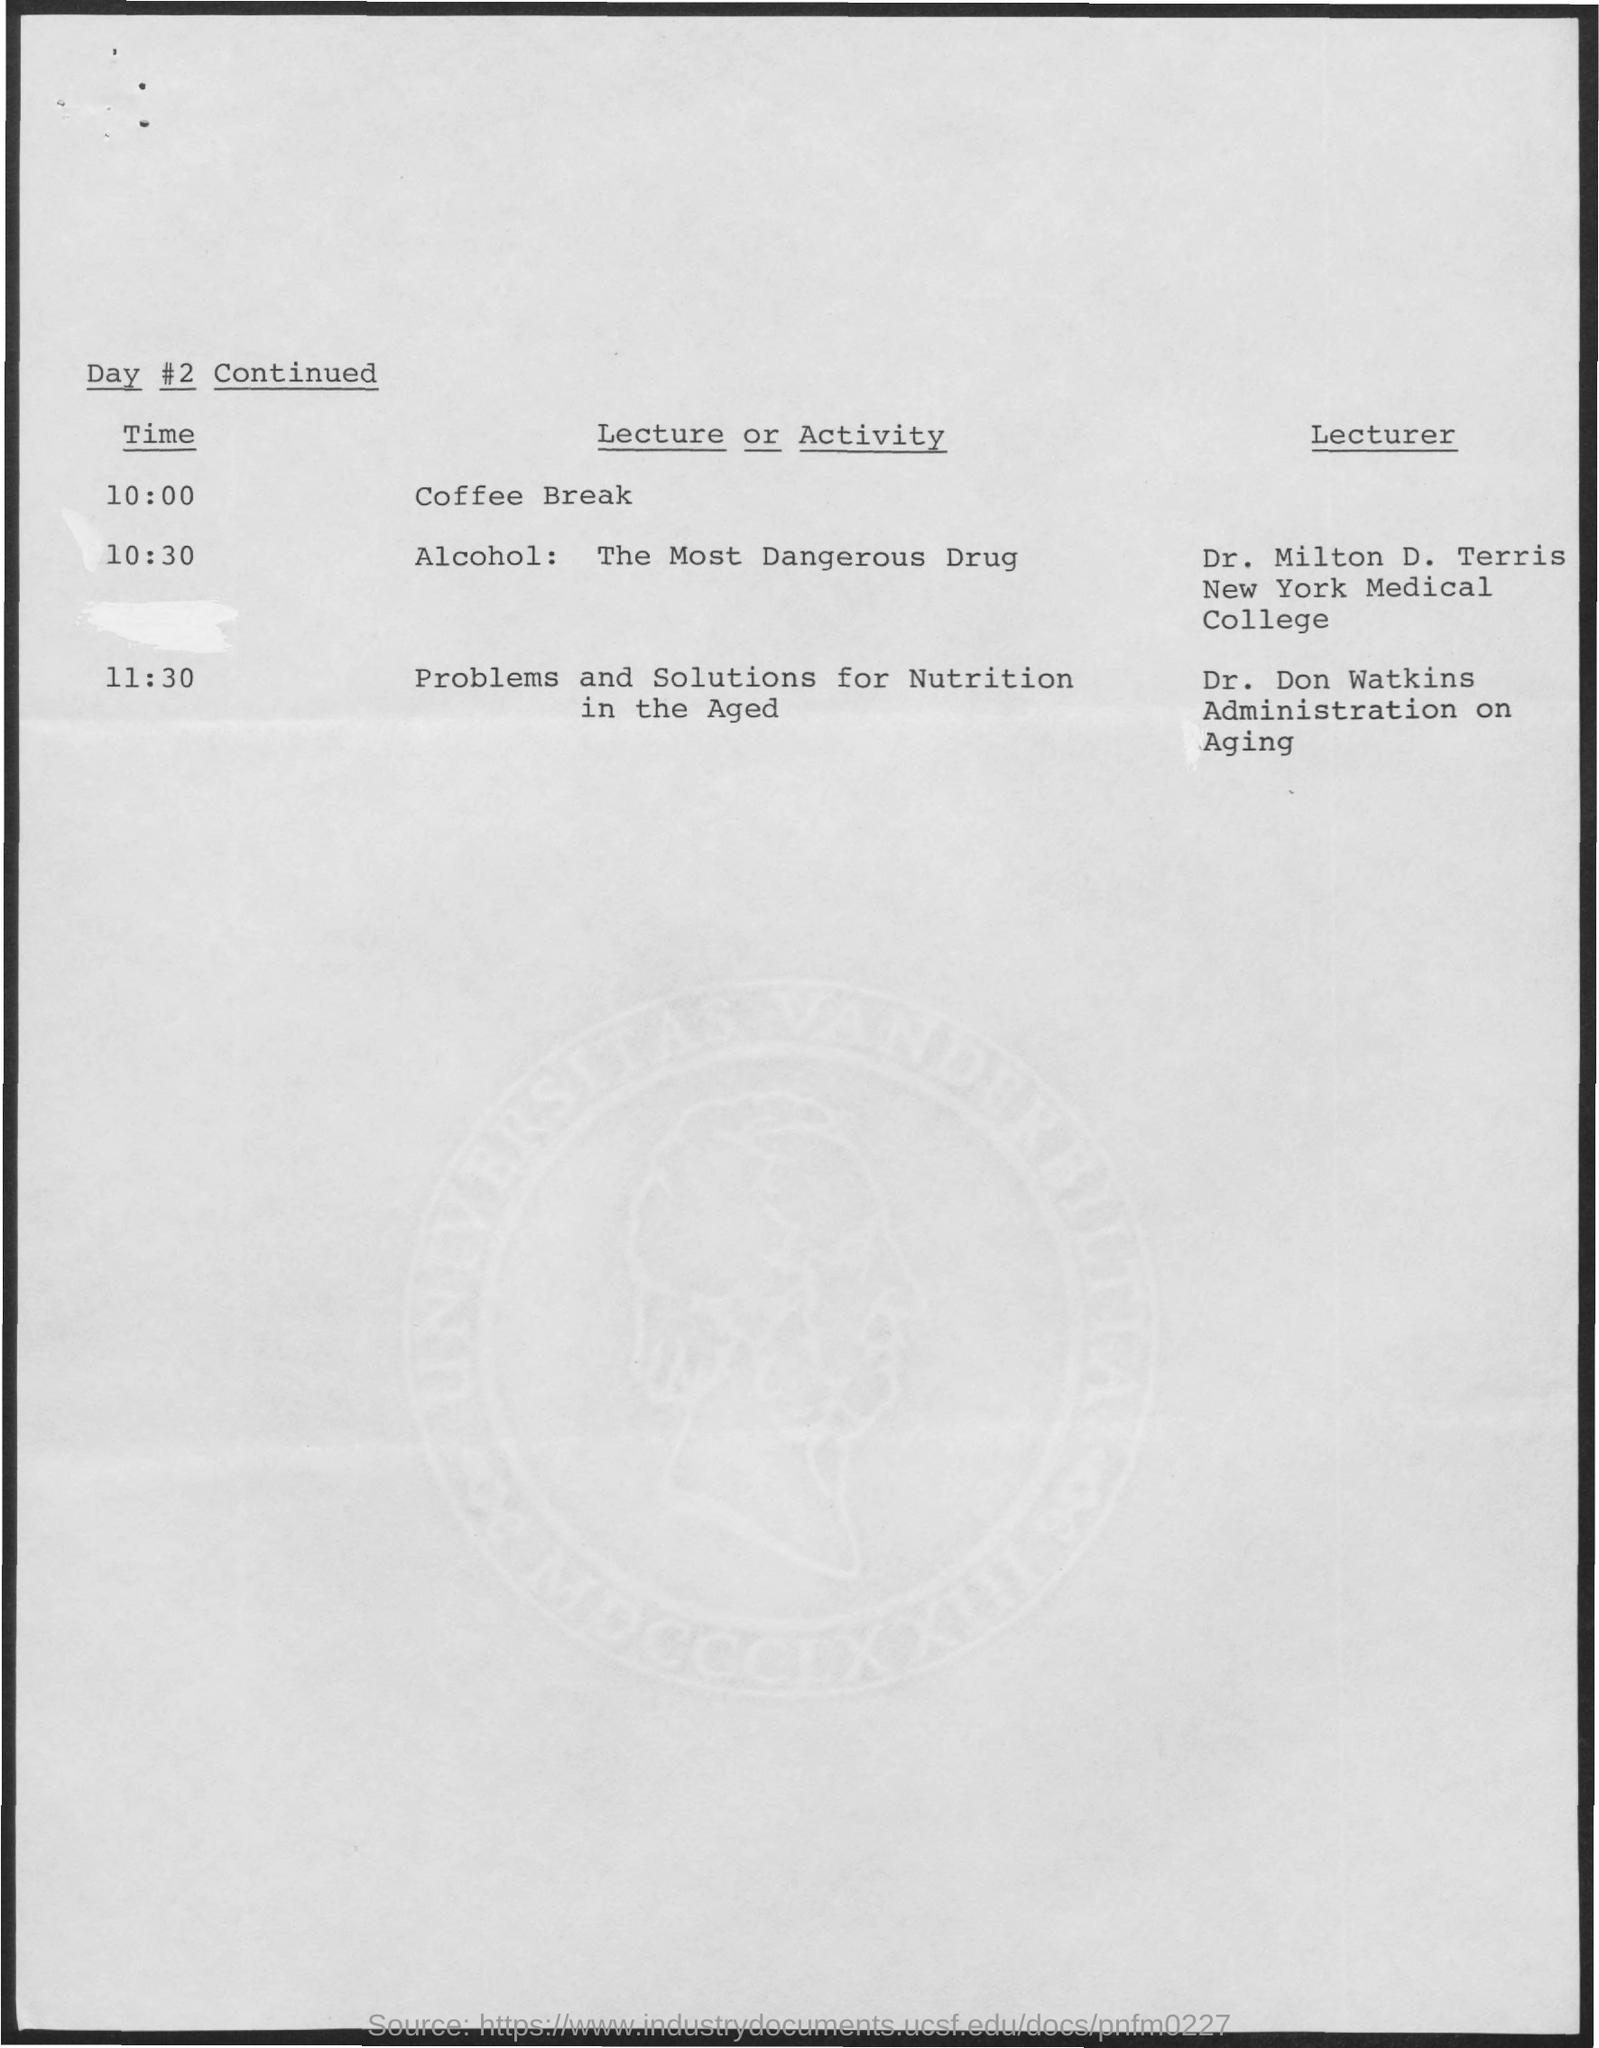Point out several critical features in this image. At 10:30, the activity being referred to is "alcohol" which is considered the most dangerous drug. At 11:30, the lecturer's name was Dr. Don Watkins. At 11:30 a.m., the activity was "Problems and Solutions for Nutrition in the Aged. The lecturer named at 10:30 is Dr. Milton D. Terris. At 10:00 am, there will be a coffee break. 